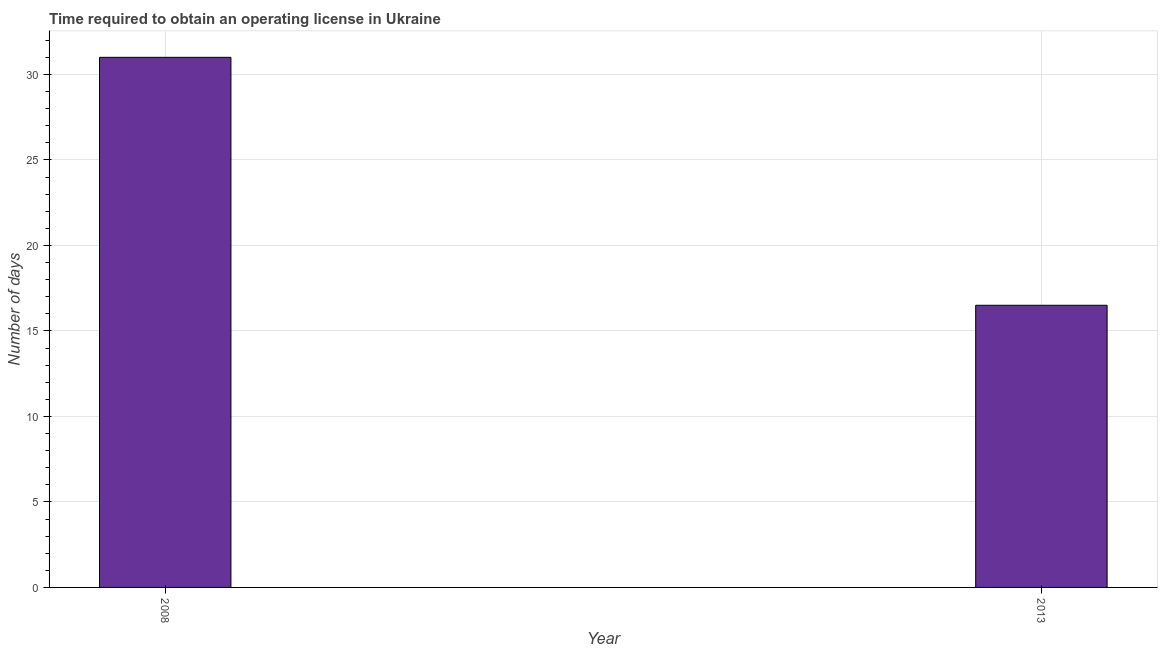Does the graph contain any zero values?
Make the answer very short. No. Does the graph contain grids?
Offer a very short reply. Yes. What is the title of the graph?
Your answer should be compact. Time required to obtain an operating license in Ukraine. What is the label or title of the Y-axis?
Your answer should be compact. Number of days. What is the number of days to obtain operating license in 2013?
Provide a short and direct response. 16.5. What is the sum of the number of days to obtain operating license?
Your answer should be very brief. 47.5. What is the average number of days to obtain operating license per year?
Your answer should be compact. 23.75. What is the median number of days to obtain operating license?
Keep it short and to the point. 23.75. What is the ratio of the number of days to obtain operating license in 2008 to that in 2013?
Keep it short and to the point. 1.88. Is the number of days to obtain operating license in 2008 less than that in 2013?
Keep it short and to the point. No. Are all the bars in the graph horizontal?
Provide a succinct answer. No. How many years are there in the graph?
Your response must be concise. 2. What is the difference between two consecutive major ticks on the Y-axis?
Keep it short and to the point. 5. What is the Number of days of 2008?
Provide a short and direct response. 31. What is the difference between the Number of days in 2008 and 2013?
Give a very brief answer. 14.5. What is the ratio of the Number of days in 2008 to that in 2013?
Offer a very short reply. 1.88. 